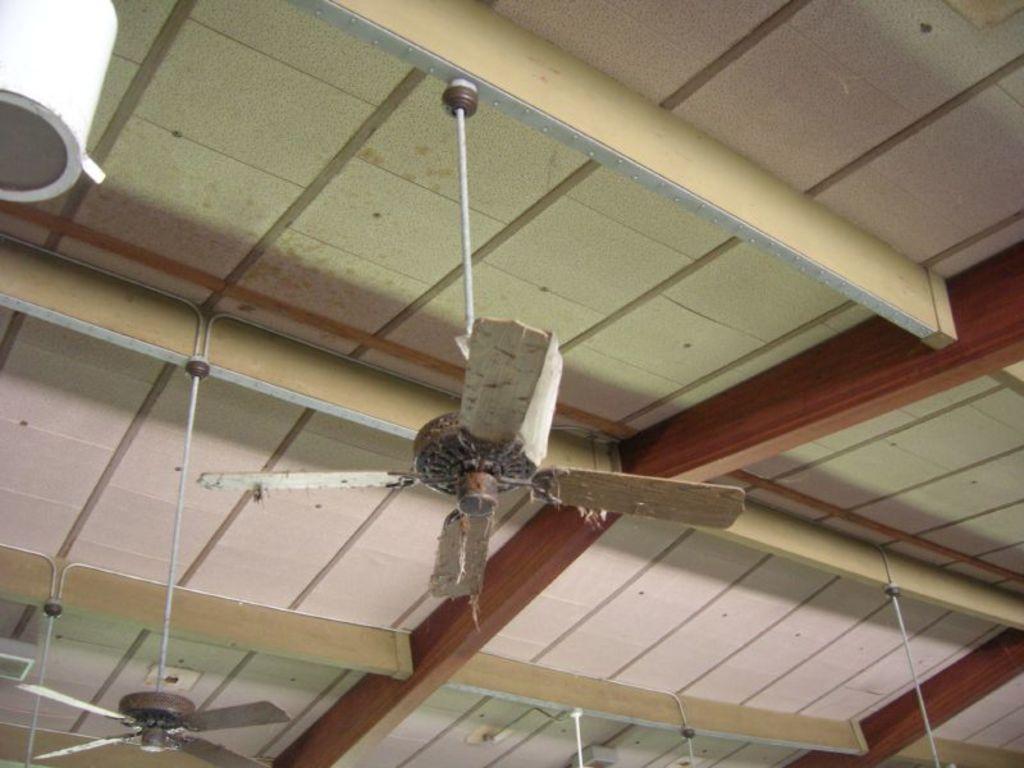Please provide a concise description of this image. In this picture I can see there is a fan attached to the ceiling and there are many more fans attached to the ceiling. It has wings, the fan is dirty, it has dust and there are few papers on it. There is a white color object placed on the ceiling and there is a wooden frame on the ceiling. 